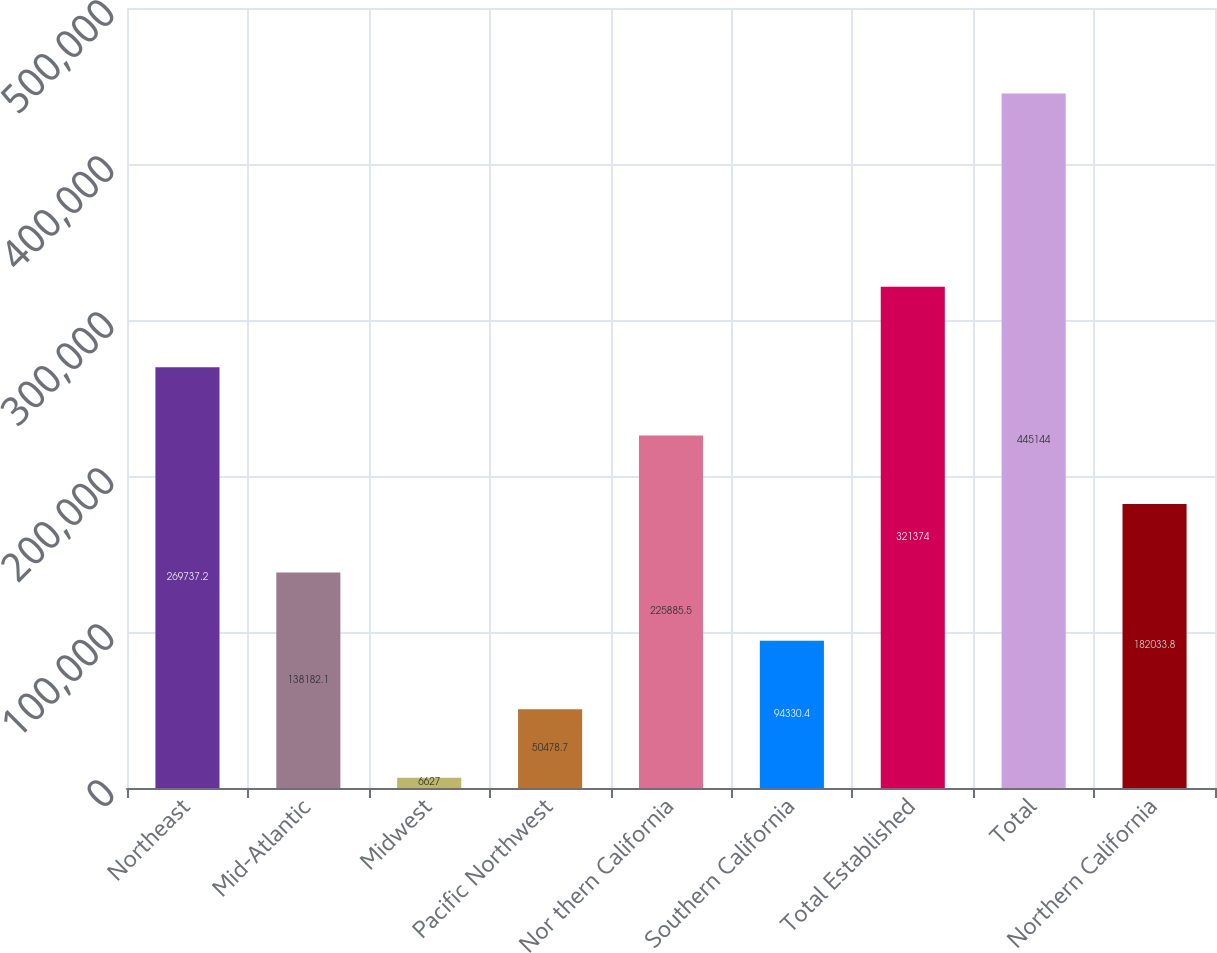Convert chart. <chart><loc_0><loc_0><loc_500><loc_500><bar_chart><fcel>Northeast<fcel>Mid-Atlantic<fcel>Midwest<fcel>Pacific Northwest<fcel>Nor thern California<fcel>Southern California<fcel>Total Established<fcel>Total<fcel>Northern California<nl><fcel>269737<fcel>138182<fcel>6627<fcel>50478.7<fcel>225886<fcel>94330.4<fcel>321374<fcel>445144<fcel>182034<nl></chart> 